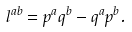<formula> <loc_0><loc_0><loc_500><loc_500>l ^ { a b } = p ^ { a } q ^ { b } - q ^ { a } p ^ { b } .</formula> 